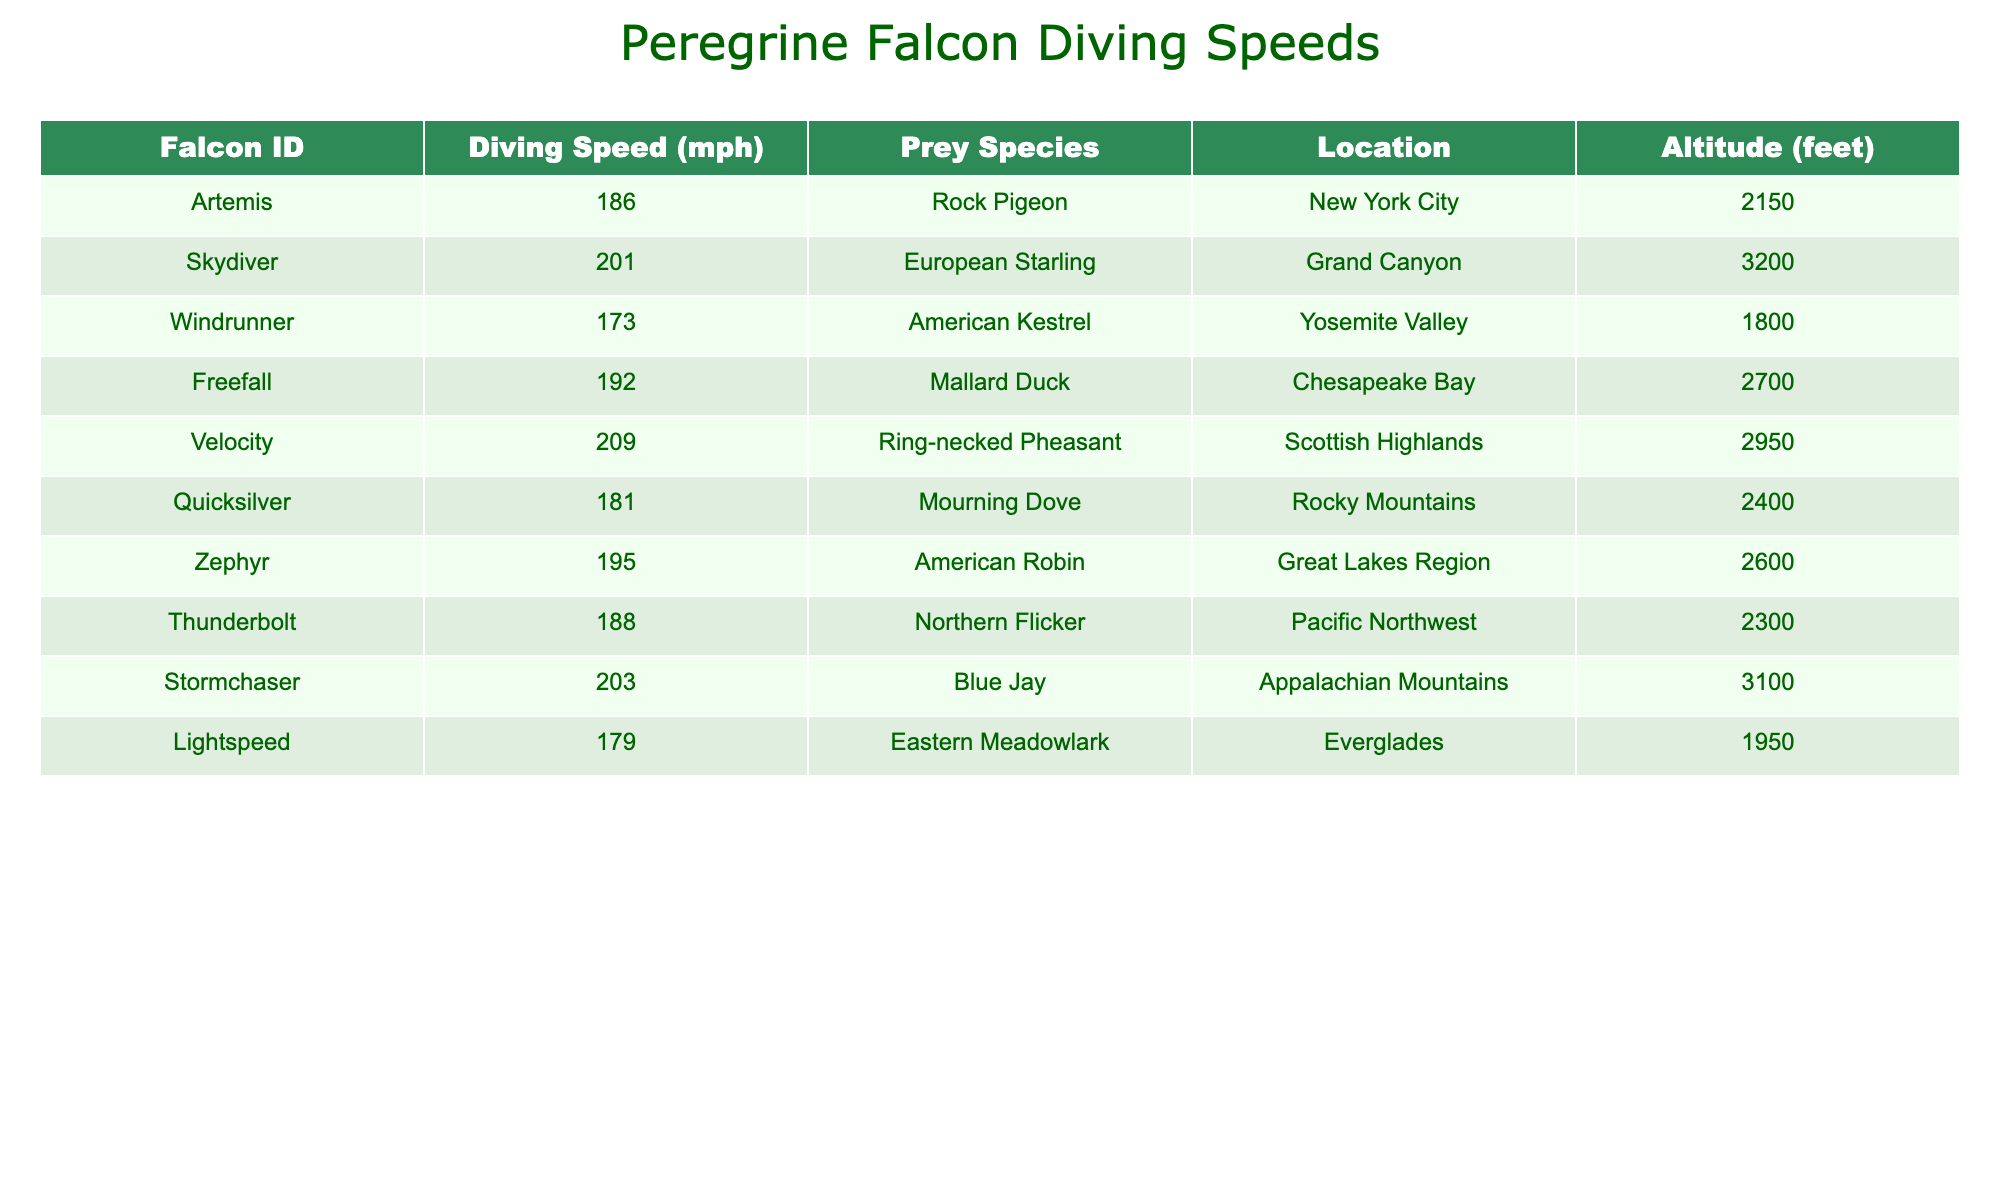What is the highest recorded diving speed of a peregrine falcon? The table lists the diving speeds, and by scanning through the values, the highest speed recorded is 209 mph for the falcon named Velocity.
Answer: 209 mph Which falcon species was recorded diving at the lowest speed? By examining the speeds in the table, the lowest recorded speed is 173 mph, which belongs to the falcon named Windrunner.
Answer: Windrunner How many falcons were recorded diving speeds of 200 mph or more? The table can be reviewed to identify the speeds of each falcon. The falcons with speeds of 200 mph or more are Skydiver, Velocity, Stormchaser, and Freefall, giving a total of 4 falcons.
Answer: 4 What is the average diving speed of all the peregrine falcons in the table? To find the average diving speed, sum all the diving speeds: 186 + 201 + 173 + 192 + 209 + 181 + 195 + 188 + 203 + 179 = 2006. Then, divide by the total number of falcons, which is 10, giving an average of 200.6 mph.
Answer: 200.6 mph Is there a falcon that hunted a Ring-necked Pheasant at an altitude higher than 2900 feet? By checking the altitude for the falcon named Velocity, who hunted a Ring-necked Pheasant at 2950 feet, it's confirmed that this falcon indeed hunted at a higher altitude than 2900 feet, making the statement true.
Answer: Yes What is the difference between the highest and lowest diving speeds of the recorded falcons? The highest speed is 209 mph (Velocity) and the lowest is 173 mph (Windrunner). The difference is 209 - 173 = 36 mph.
Answer: 36 mph Which prey species corresponds to the falcon with the second-highest diving speed? Looking through the table, the second-highest speed is 201 mph associated with the falcon Skydiver, which hunted a European Starling.
Answer: European Starling Are there more falcons that recorded diving speeds above 190 mph compared to those below? The speeds above 190 mph include Artemis, Skydiver, Freefall, Velocity, Zephyr, and Stormchaser, totaling 6 falcons. The speeds below 190 mph are Windrunner, Quicksilver, Thunderbolt, and Lightspeed, totaling 4 falcons. Since 6 is greater than 4, the answer is yes.
Answer: Yes What prey species did Thunderbolt hunt and what was its diving speed? In the table, Thunderbolt is associated with 188 mph, and it hunted a Northern Flicker.
Answer: Northern Flicker, 188 mph 